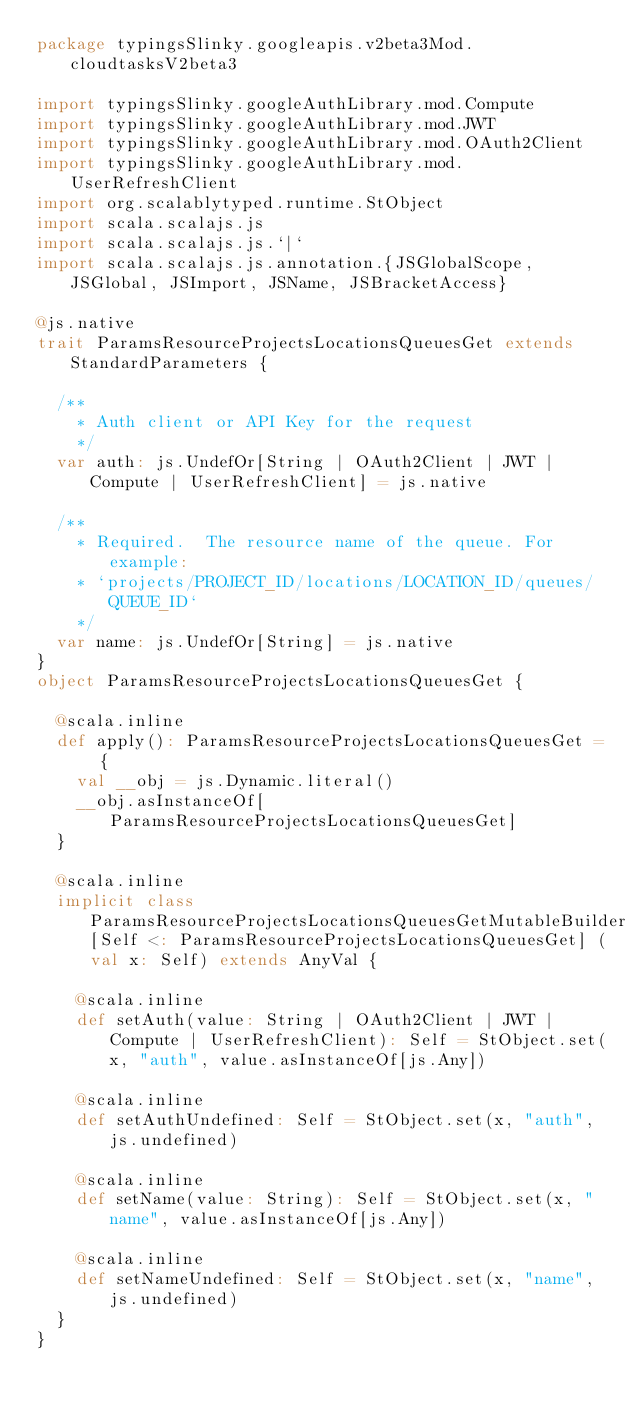<code> <loc_0><loc_0><loc_500><loc_500><_Scala_>package typingsSlinky.googleapis.v2beta3Mod.cloudtasksV2beta3

import typingsSlinky.googleAuthLibrary.mod.Compute
import typingsSlinky.googleAuthLibrary.mod.JWT
import typingsSlinky.googleAuthLibrary.mod.OAuth2Client
import typingsSlinky.googleAuthLibrary.mod.UserRefreshClient
import org.scalablytyped.runtime.StObject
import scala.scalajs.js
import scala.scalajs.js.`|`
import scala.scalajs.js.annotation.{JSGlobalScope, JSGlobal, JSImport, JSName, JSBracketAccess}

@js.native
trait ParamsResourceProjectsLocationsQueuesGet extends StandardParameters {
  
  /**
    * Auth client or API Key for the request
    */
  var auth: js.UndefOr[String | OAuth2Client | JWT | Compute | UserRefreshClient] = js.native
  
  /**
    * Required.  The resource name of the queue. For example:
    * `projects/PROJECT_ID/locations/LOCATION_ID/queues/QUEUE_ID`
    */
  var name: js.UndefOr[String] = js.native
}
object ParamsResourceProjectsLocationsQueuesGet {
  
  @scala.inline
  def apply(): ParamsResourceProjectsLocationsQueuesGet = {
    val __obj = js.Dynamic.literal()
    __obj.asInstanceOf[ParamsResourceProjectsLocationsQueuesGet]
  }
  
  @scala.inline
  implicit class ParamsResourceProjectsLocationsQueuesGetMutableBuilder[Self <: ParamsResourceProjectsLocationsQueuesGet] (val x: Self) extends AnyVal {
    
    @scala.inline
    def setAuth(value: String | OAuth2Client | JWT | Compute | UserRefreshClient): Self = StObject.set(x, "auth", value.asInstanceOf[js.Any])
    
    @scala.inline
    def setAuthUndefined: Self = StObject.set(x, "auth", js.undefined)
    
    @scala.inline
    def setName(value: String): Self = StObject.set(x, "name", value.asInstanceOf[js.Any])
    
    @scala.inline
    def setNameUndefined: Self = StObject.set(x, "name", js.undefined)
  }
}
</code> 